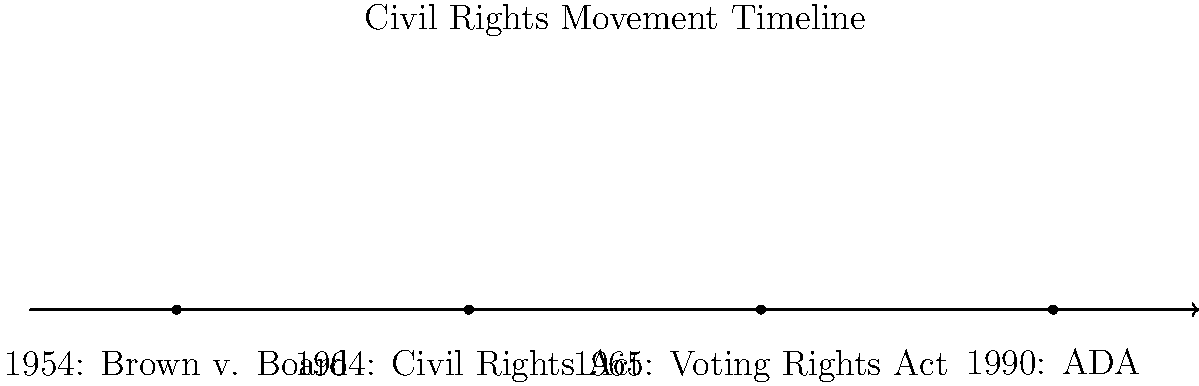Based on the infographic, which landmark legislation was enacted in 1964 that significantly advanced civil rights in the United States? To answer this question, we need to follow these steps:

1. Examine the timeline presented in the infographic.
2. Identify the events and their corresponding years.
3. Look specifically for an event in 1964.
4. Determine the legislation associated with that year.

Following these steps:

1. The timeline shows four significant events in the civil rights movement.
2. The events and years are:
   - 1954: Brown v. Board
   - 1964: Civil Rights Act
   - 1965: Voting Rights Act
   - 1990: ADA (Americans with Disabilities Act)
3. We can see an event listed for 1964.
4. The legislation associated with 1964 is the Civil Rights Act.

Therefore, the landmark legislation enacted in 1964 that significantly advanced civil rights in the United States was the Civil Rights Act.
Answer: Civil Rights Act 